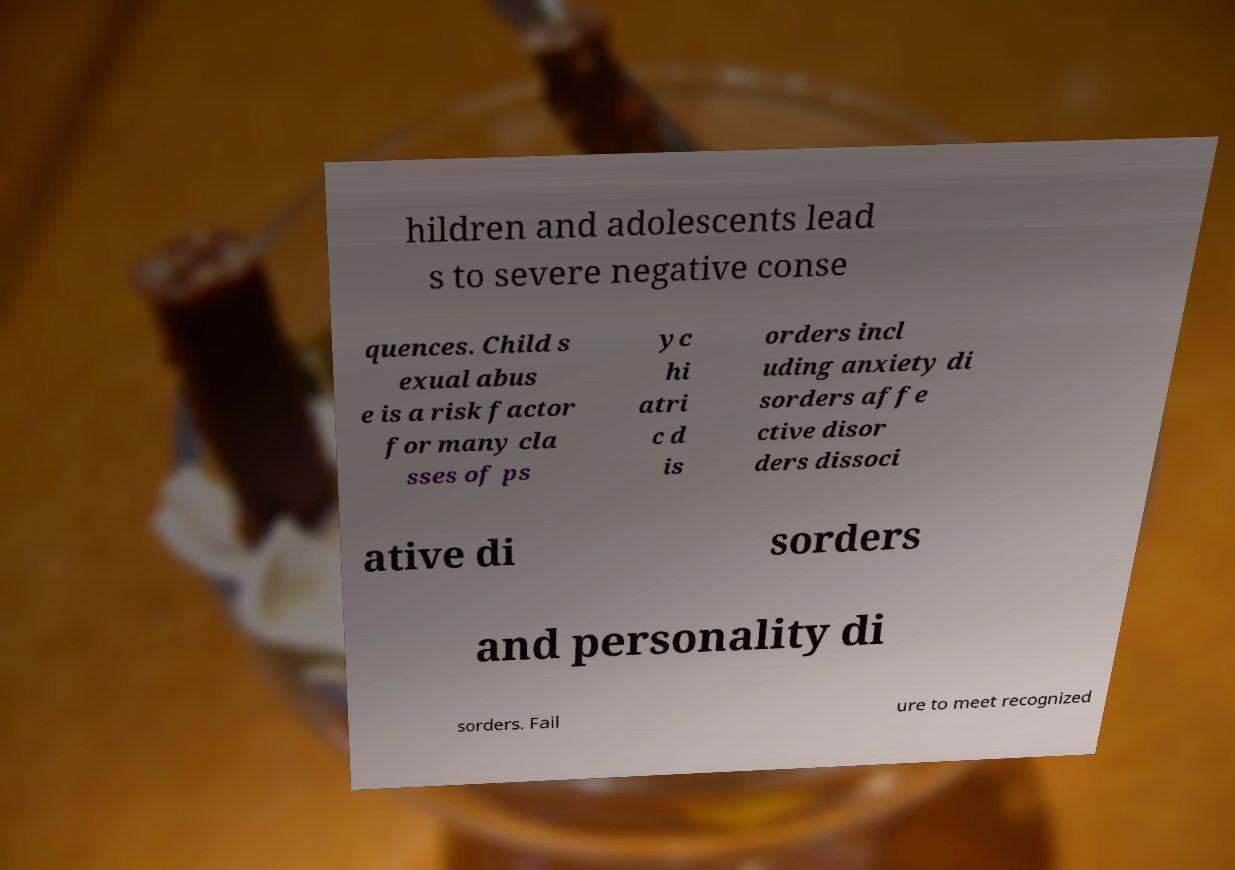I need the written content from this picture converted into text. Can you do that? hildren and adolescents lead s to severe negative conse quences. Child s exual abus e is a risk factor for many cla sses of ps yc hi atri c d is orders incl uding anxiety di sorders affe ctive disor ders dissoci ative di sorders and personality di sorders. Fail ure to meet recognized 